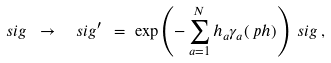Convert formula to latex. <formula><loc_0><loc_0><loc_500><loc_500>\ s i g \ \to \ \ s i g ^ { \prime } \ & = \ \exp \left ( - \sum _ { a = 1 } ^ { N } h _ { a } \gamma _ { a } ( \ p h ) \right ) \ s i g \, ,</formula> 